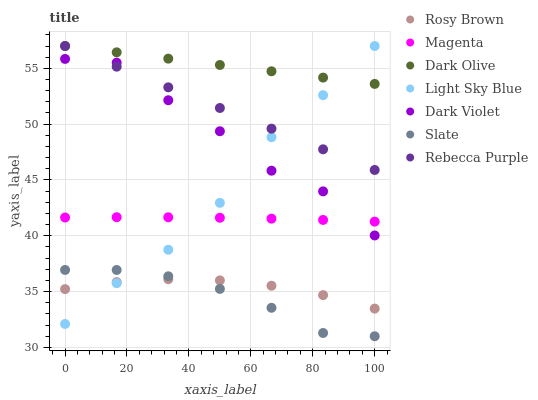Does Slate have the minimum area under the curve?
Answer yes or no. Yes. Does Dark Olive have the maximum area under the curve?
Answer yes or no. Yes. Does Dark Olive have the minimum area under the curve?
Answer yes or no. No. Does Slate have the maximum area under the curve?
Answer yes or no. No. Is Rebecca Purple the smoothest?
Answer yes or no. Yes. Is Dark Violet the roughest?
Answer yes or no. Yes. Is Slate the smoothest?
Answer yes or no. No. Is Slate the roughest?
Answer yes or no. No. Does Slate have the lowest value?
Answer yes or no. Yes. Does Dark Olive have the lowest value?
Answer yes or no. No. Does Rebecca Purple have the highest value?
Answer yes or no. Yes. Does Slate have the highest value?
Answer yes or no. No. Is Slate less than Dark Violet?
Answer yes or no. Yes. Is Dark Violet greater than Rosy Brown?
Answer yes or no. Yes. Does Light Sky Blue intersect Dark Olive?
Answer yes or no. Yes. Is Light Sky Blue less than Dark Olive?
Answer yes or no. No. Is Light Sky Blue greater than Dark Olive?
Answer yes or no. No. Does Slate intersect Dark Violet?
Answer yes or no. No. 